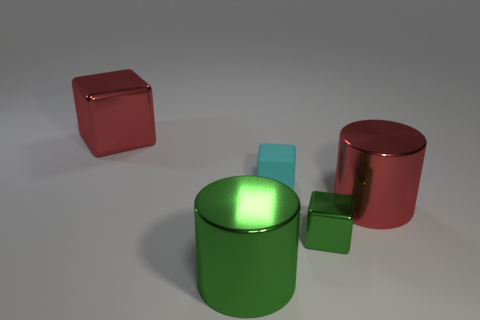There is a tiny green metal object; what shape is it?
Provide a succinct answer. Cube. There is a large red thing left of the cylinder that is on the right side of the small cyan rubber block; what shape is it?
Provide a succinct answer. Cube. Is the large red object that is behind the tiny cyan rubber block made of the same material as the small cyan thing?
Your response must be concise. No. How many cyan things are either tiny objects or shiny cubes?
Ensure brevity in your answer.  1. Are there any small rubber things that have the same color as the small metal thing?
Your answer should be very brief. No. Are there any other large red cylinders made of the same material as the big red cylinder?
Your response must be concise. No. There is a large object that is on the left side of the tiny green cube and behind the green block; what shape is it?
Your answer should be compact. Cube. What number of big things are purple objects or metal objects?
Keep it short and to the point. 3. What is the material of the red block?
Offer a terse response. Metal. How many other things are the same shape as the small green metal object?
Offer a terse response. 2. 